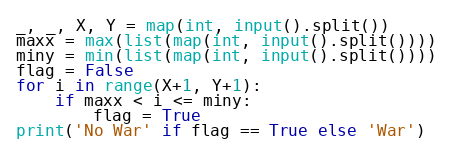<code> <loc_0><loc_0><loc_500><loc_500><_Python_>_, _, X, Y = map(int, input().split())
maxx = max(list(map(int, input().split())))
miny = min(list(map(int, input().split())))
flag = False
for i in range(X+1, Y+1):
    if maxx < i <= miny:
        flag = True
print('No War' if flag == True else 'War')</code> 